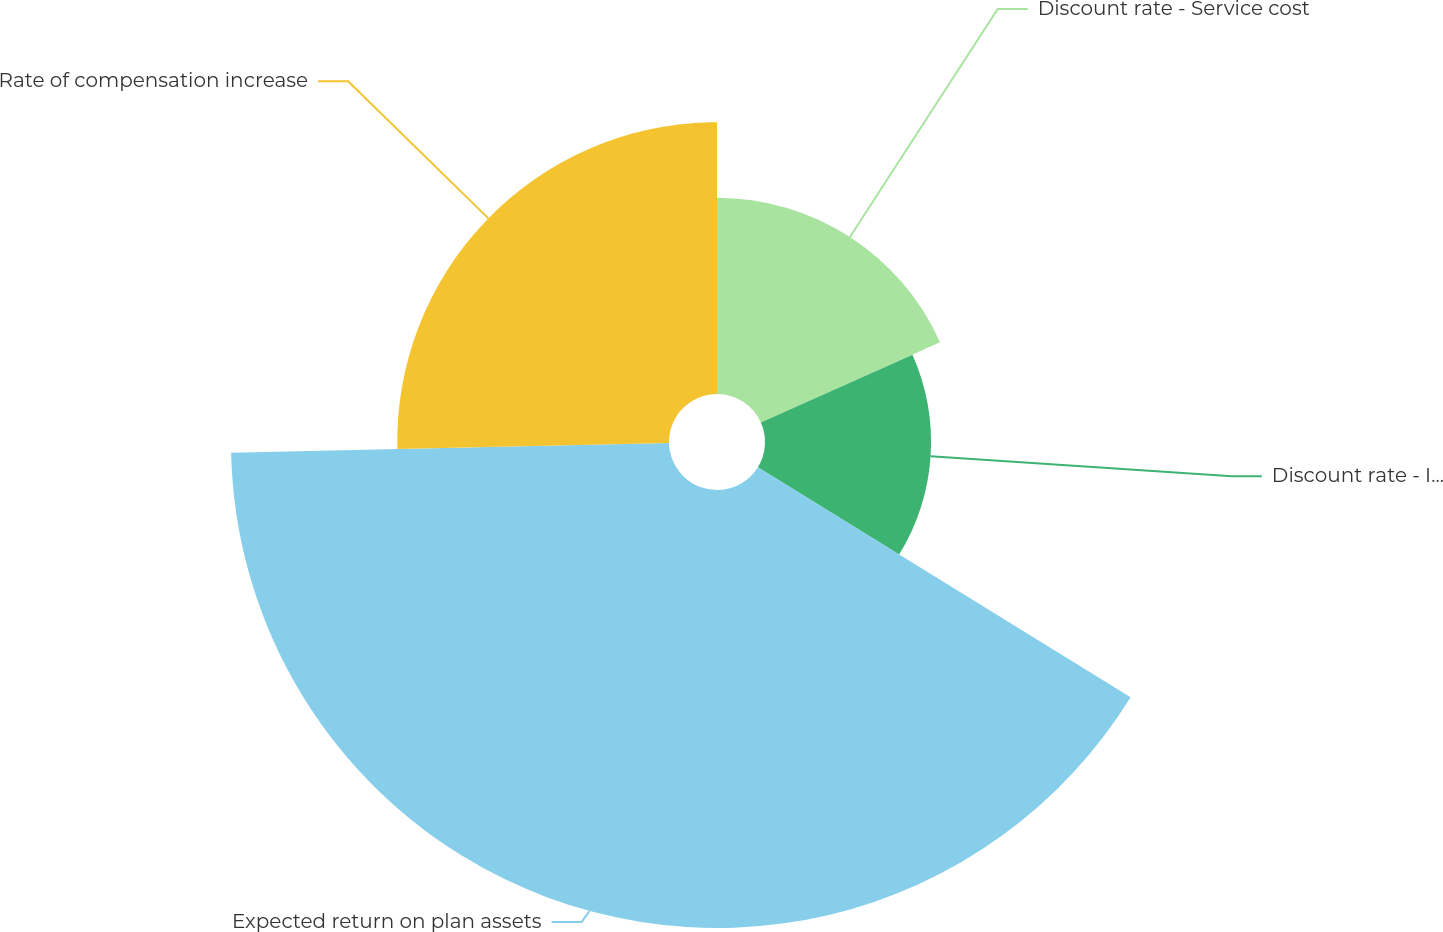Convert chart. <chart><loc_0><loc_0><loc_500><loc_500><pie_chart><fcel>Discount rate - Service cost<fcel>Discount rate - Interest cost<fcel>Expected return on plan assets<fcel>Rate of compensation increase<nl><fcel>18.31%<fcel>15.49%<fcel>40.85%<fcel>25.35%<nl></chart> 